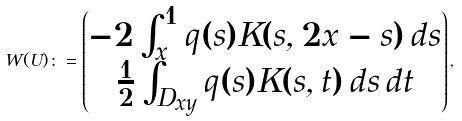Convert formula to latex. <formula><loc_0><loc_0><loc_500><loc_500>W ( U ) \colon = \begin{pmatrix} - 2 \int ^ { 1 } _ { x } q ( s ) K ( s , 2 x - s ) \, d s \\ \frac { 1 } { 2 } \int _ { D _ { x y } } q ( s ) K ( s , t ) \, d s \, d t \end{pmatrix} ,</formula> 